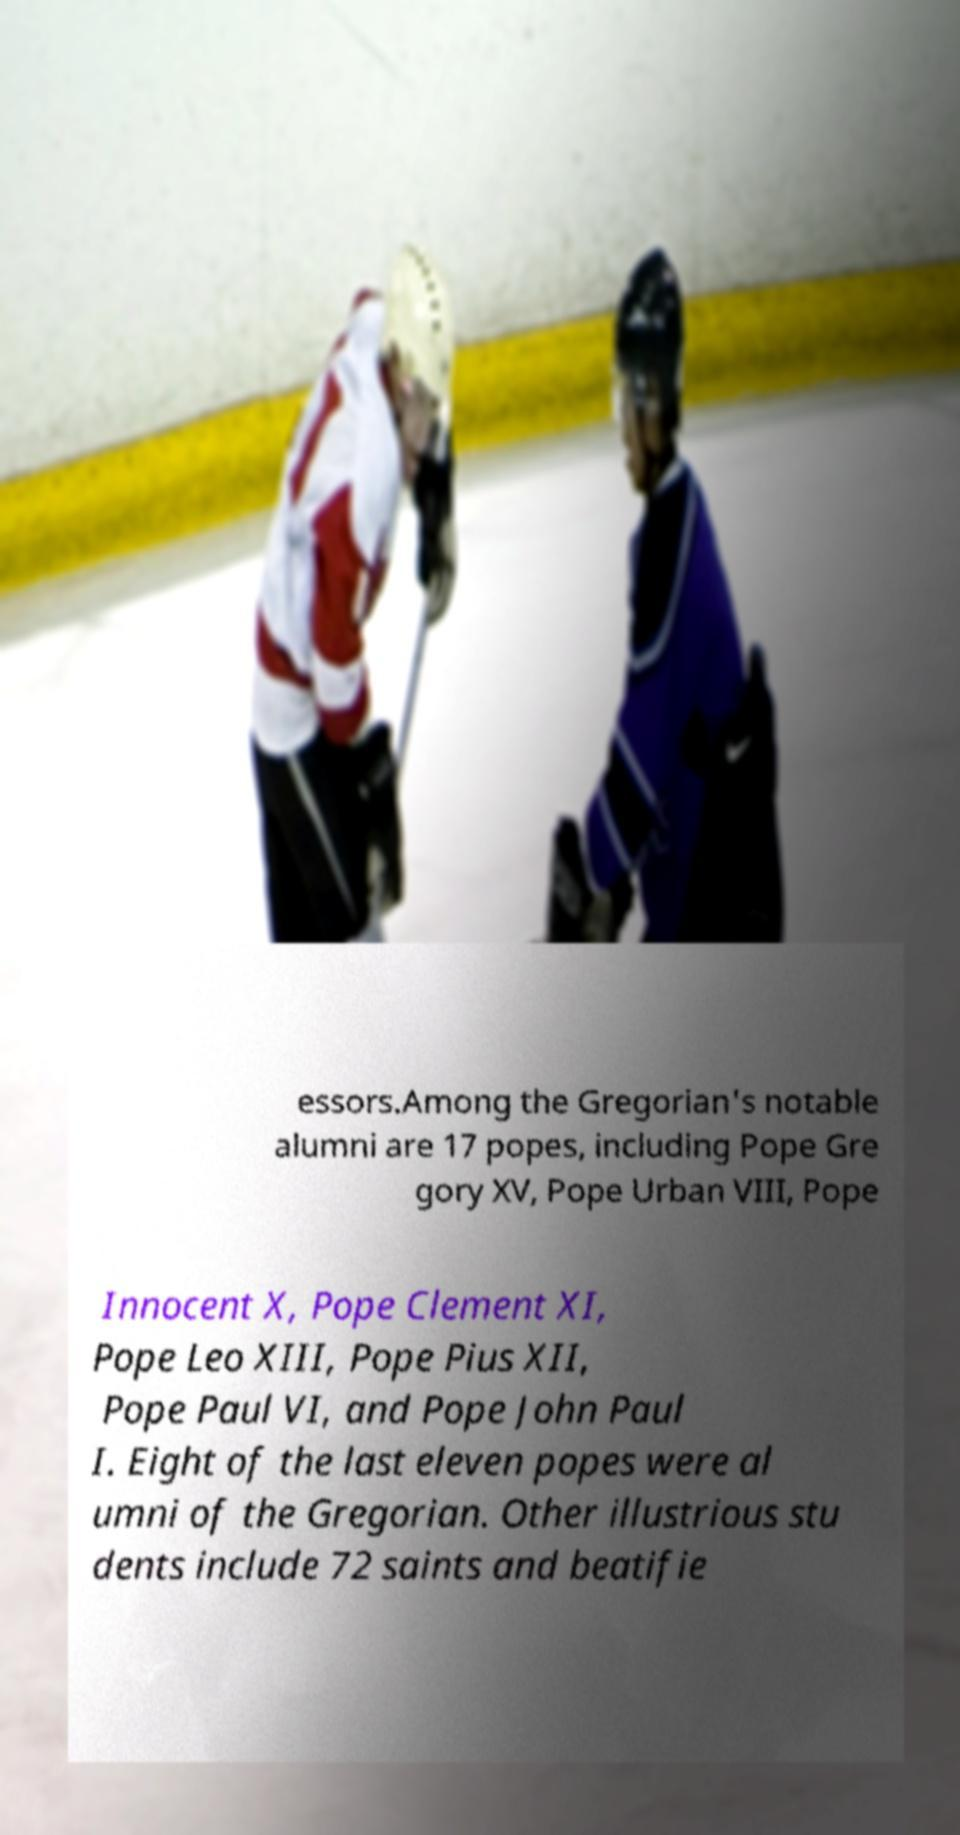Could you assist in decoding the text presented in this image and type it out clearly? essors.Among the Gregorian's notable alumni are 17 popes, including Pope Gre gory XV, Pope Urban VIII, Pope Innocent X, Pope Clement XI, Pope Leo XIII, Pope Pius XII, Pope Paul VI, and Pope John Paul I. Eight of the last eleven popes were al umni of the Gregorian. Other illustrious stu dents include 72 saints and beatifie 